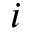<formula> <loc_0><loc_0><loc_500><loc_500>i</formula> 